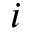<formula> <loc_0><loc_0><loc_500><loc_500>i</formula> 